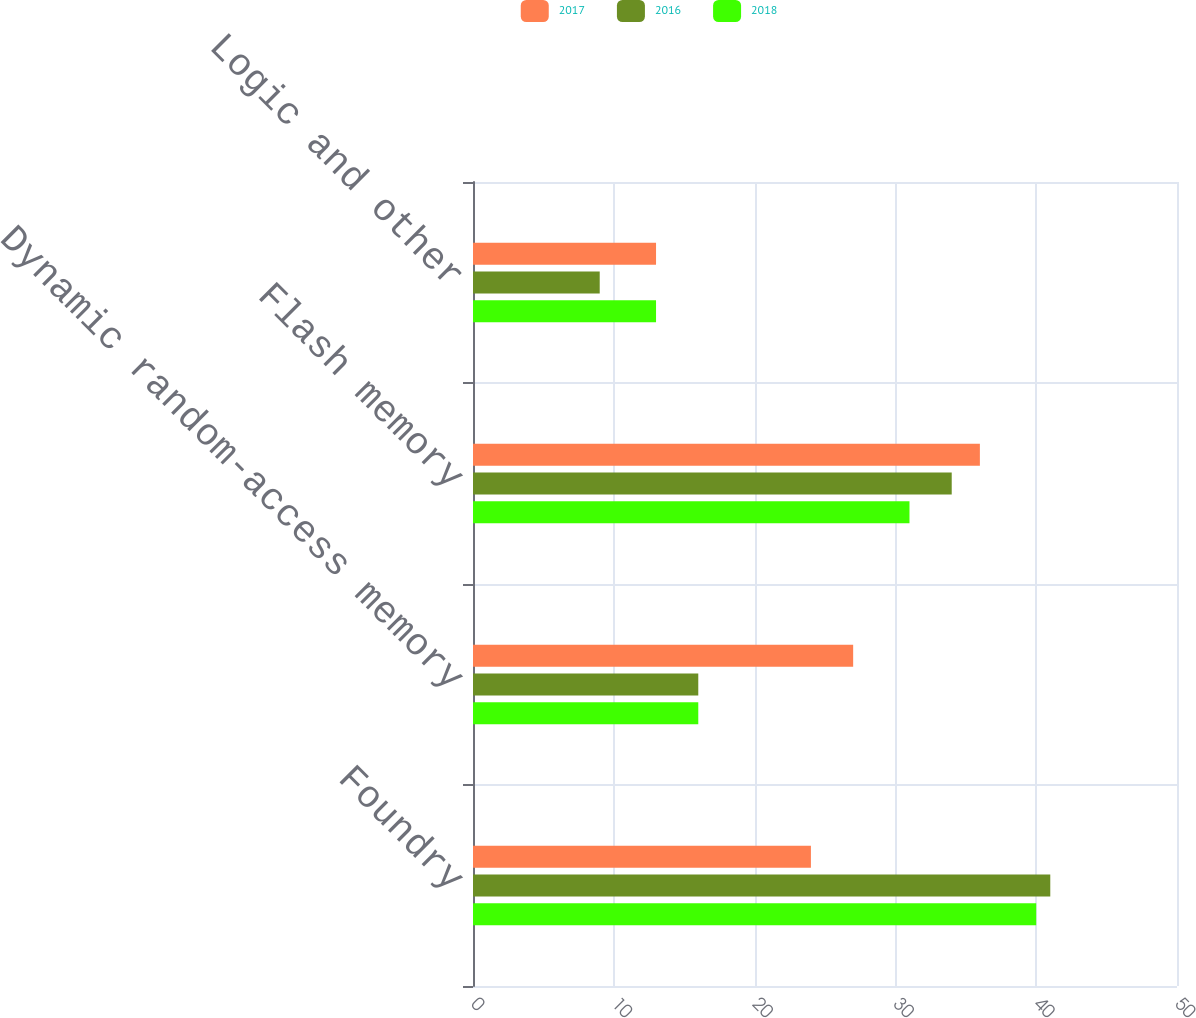Convert chart to OTSL. <chart><loc_0><loc_0><loc_500><loc_500><stacked_bar_chart><ecel><fcel>Foundry<fcel>Dynamic random-access memory<fcel>Flash memory<fcel>Logic and other<nl><fcel>2017<fcel>24<fcel>27<fcel>36<fcel>13<nl><fcel>2016<fcel>41<fcel>16<fcel>34<fcel>9<nl><fcel>2018<fcel>40<fcel>16<fcel>31<fcel>13<nl></chart> 